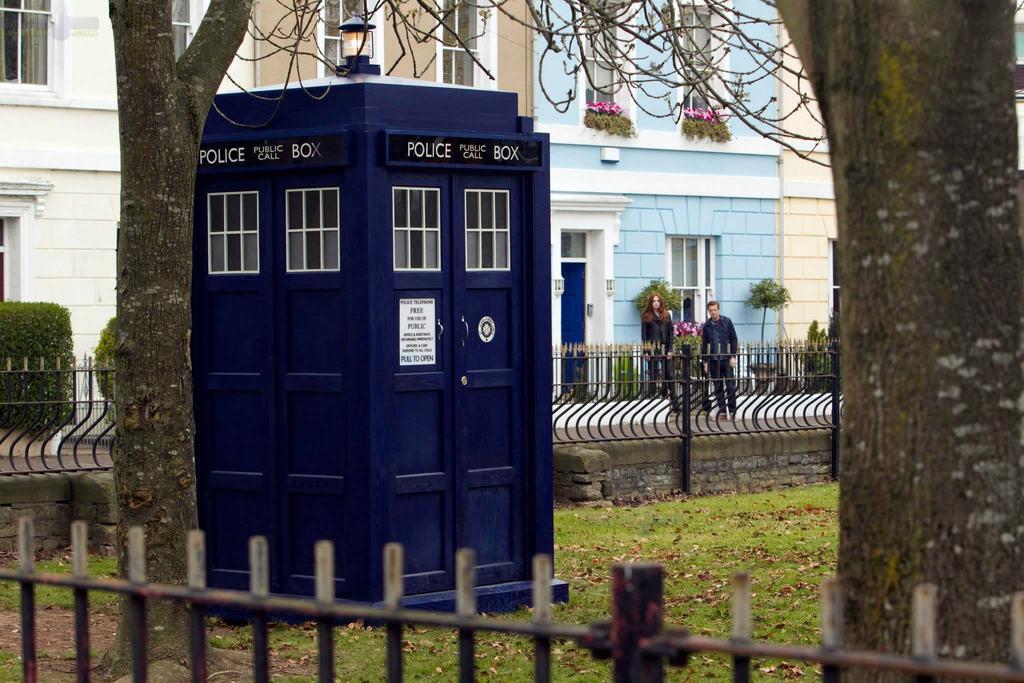In one or two sentences, can you explain what this image depicts? In the foreground of the picture there are trees, dry leaves, glass, railing and a small room with blue doors. In the background there are houses, people, plants, railing, flowers, windows, doors and other objects. 